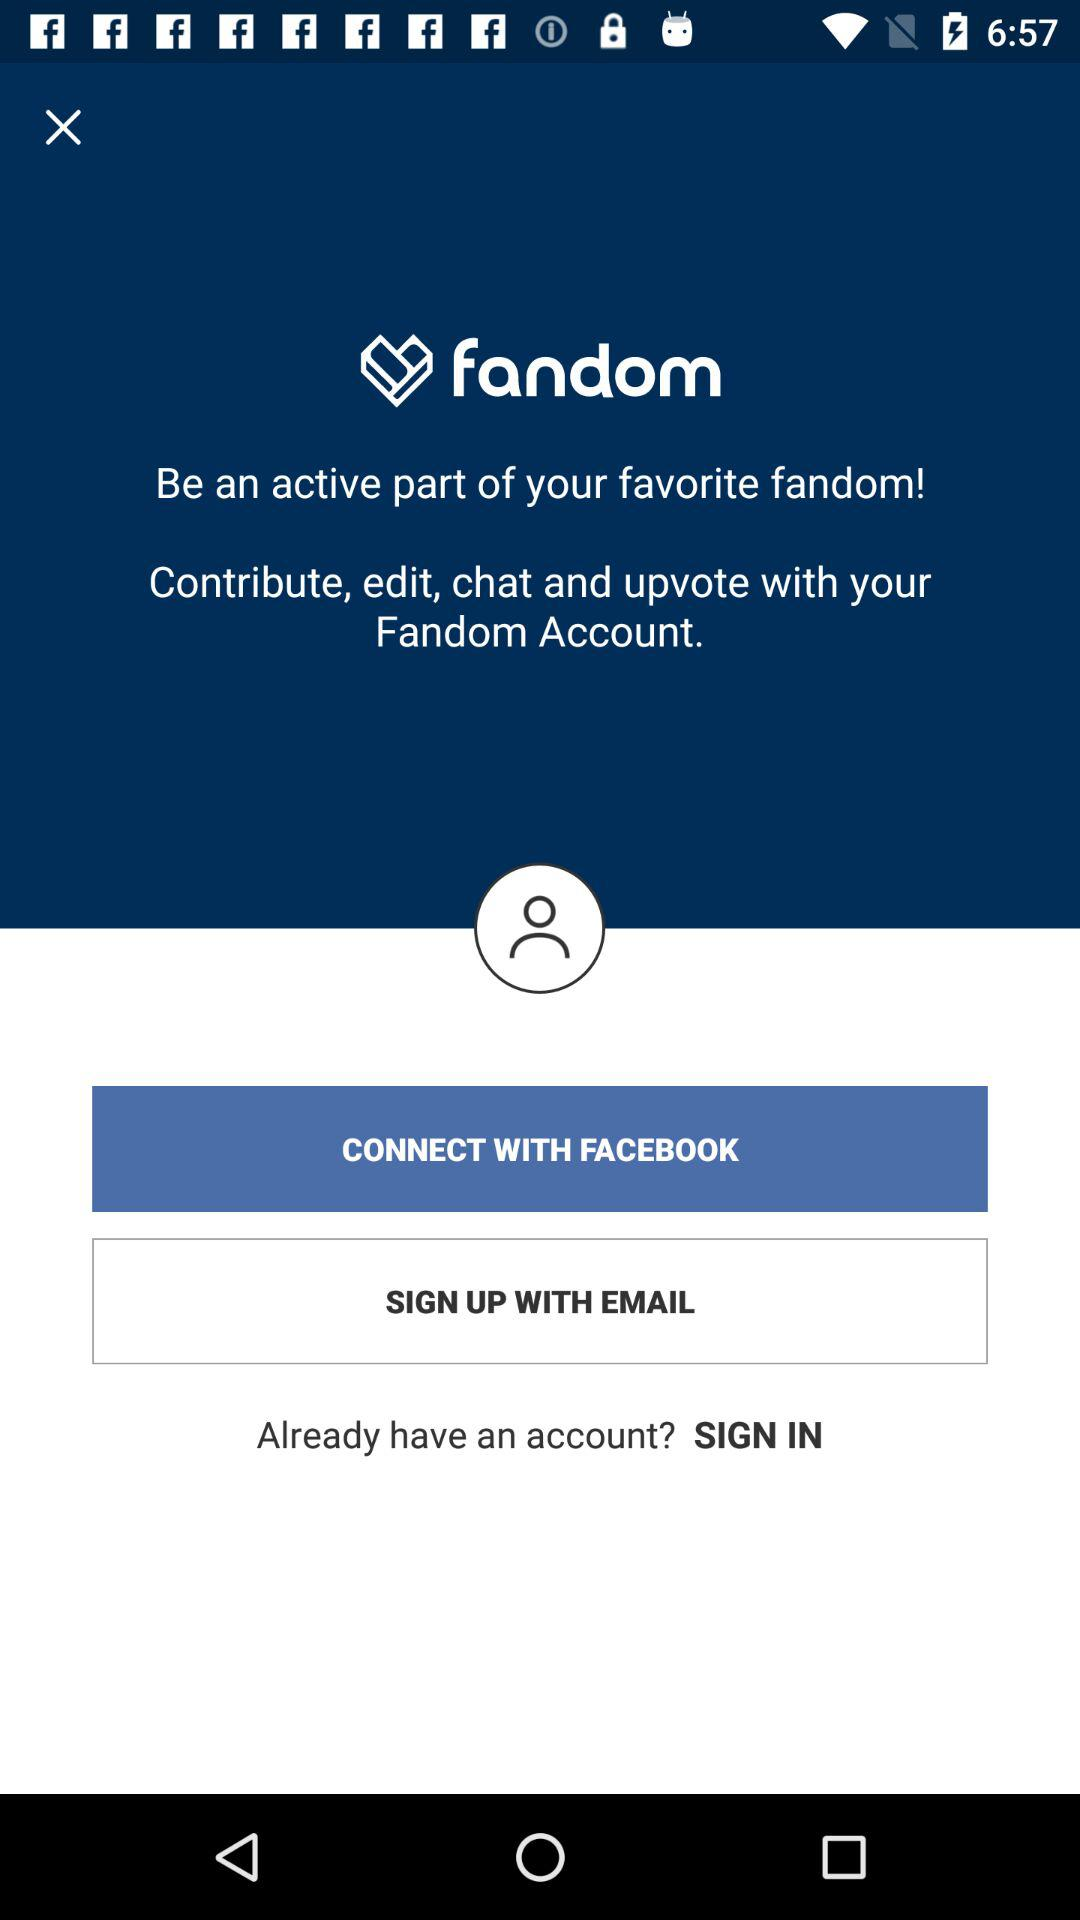What are the different options available for logging in? The different options available for logging in are "FACEBOOK" and "EMAIL". 